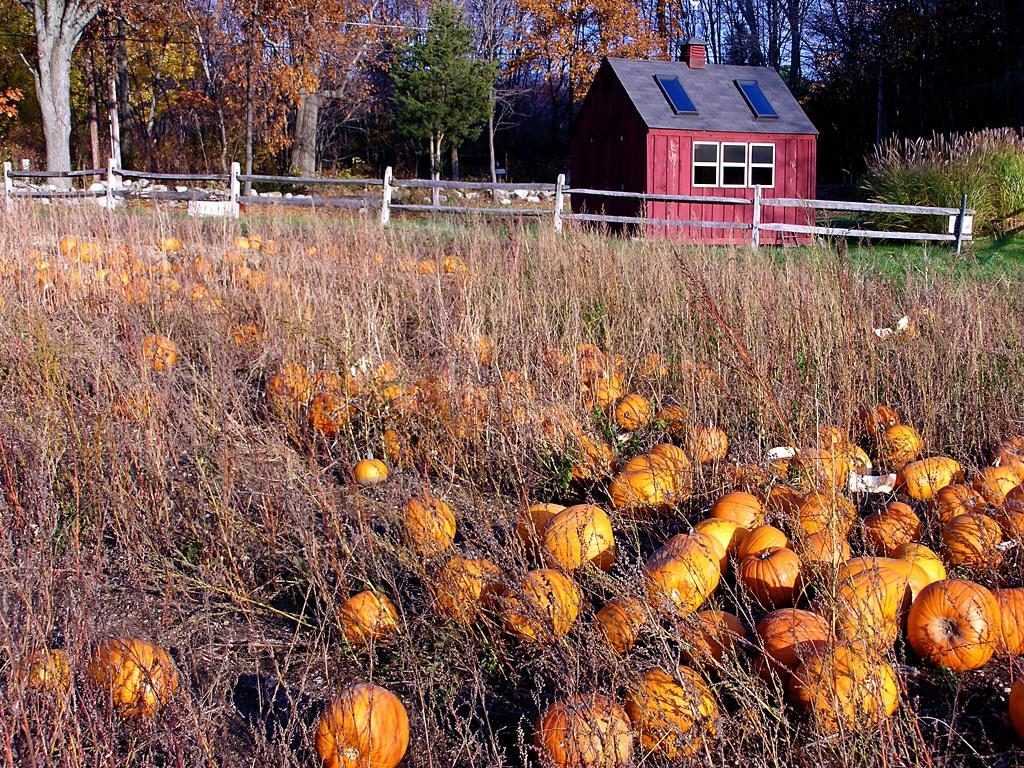What type of vegetation is present in the image? There are pumpkins in the image. What is the surface on which the pumpkins are placed? There is grass on the surface in the image. What type of barrier can be seen in the image? There is a wooden fence in the image. What type of structure is visible in the image? There is a house in the image. What can be seen in the distance in the image? There are trees and plants in the background of the image. What type of notebook is being used by the family in the image? There is no notebook or family present in the image; it features pumpkins, grass, a wooden fence, a house, and background vegetation. 